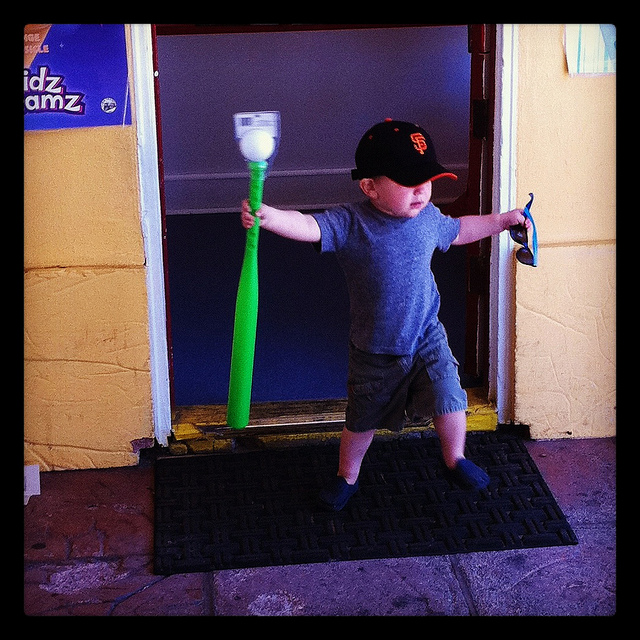Read and extract the text from this image. idz amz 5 GE 